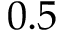Convert formula to latex. <formula><loc_0><loc_0><loc_500><loc_500>0 . 5</formula> 